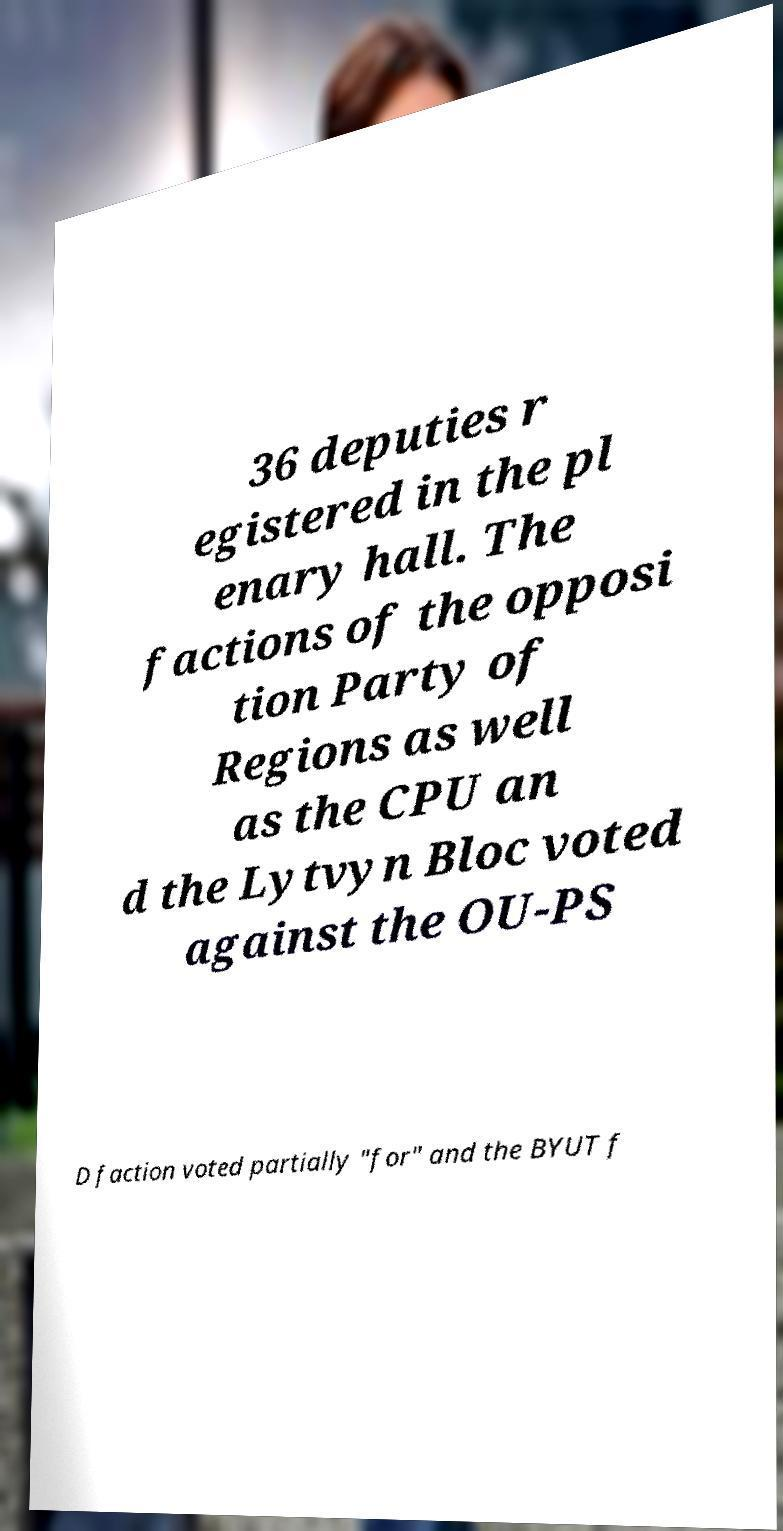Could you assist in decoding the text presented in this image and type it out clearly? 36 deputies r egistered in the pl enary hall. The factions of the opposi tion Party of Regions as well as the CPU an d the Lytvyn Bloc voted against the OU-PS D faction voted partially "for" and the BYUT f 